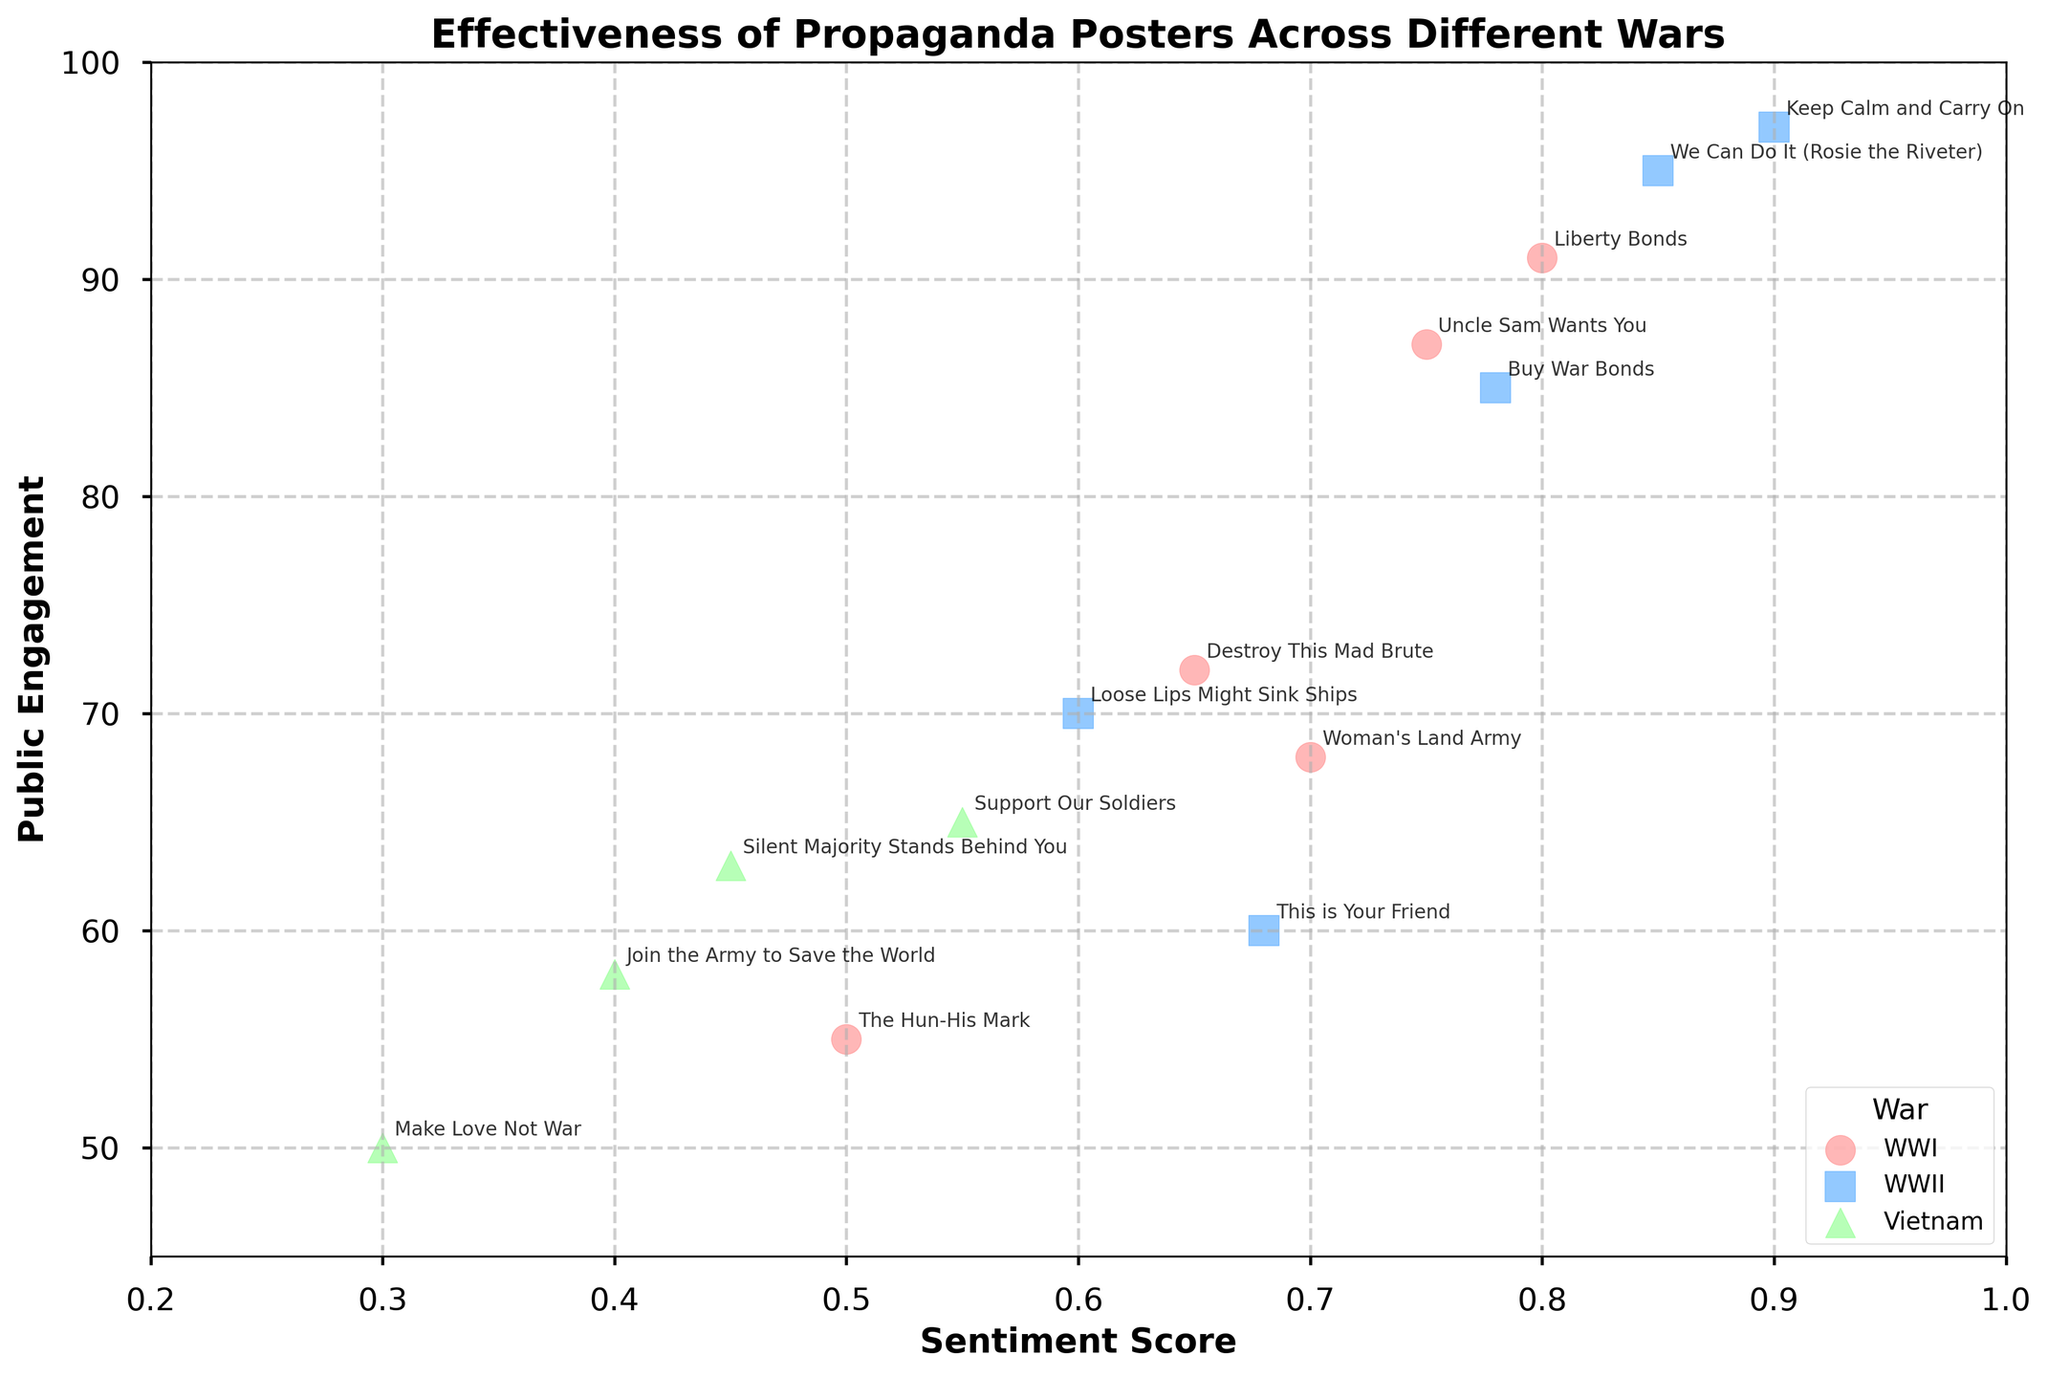What's the title of the figure? The title is typically found at the top or above the figure. Here, it states "Effectiveness of Propaganda Posters Across Different Wars".
Answer: Effectiveness of Propaganda Posters Across Different Wars How many wars are depicted in the scatter plot? The legend at the bottom right of the figure indicates each war represented by different markers and colors. The three wars are WWI, WWII, and Vietnam.
Answer: 3 Which war has the highest public engagement for a poster? By looking at the data points' y-axis values for each war, we see that WWII's "Keep Calm and Carry On" has the highest public engagement at 97.
Answer: WWII What is the general relationship between sentiment score and public engagement for WWII posters? Observing the scatter points for WWII, the trend indicates that higher sentiment scores generally correlate with higher public engagement, with peaks around 0.9 sentiment scoring 97 engagement.
Answer: Positive correlation Which poster has the lowest sentiment score in the Vietnam war, and what is its public engagement? By checking the data points for Vietnam, "Make Love Not War" has the lowest sentiment score at 0.30 with a public engagement of 50.
Answer: Make Love Not War, 50 What is the difference in sentiment score between "Uncle Sam Wants You" and "Loose Lips Might Sink Ships"? "Uncle Sam Wants You" has a sentiment score of 0.75, and "Loose Lips Might Sink Ships" has 0.60. The difference is 0.75 - 0.60.
Answer: 0.15 Looking at WWI posters, which one has the highest public engagement, and how much is it? Observing the WWI data points, "Liberty Bonds" has the highest public engagement at 91.
Answer: Liberty Bonds, 91 What is the median sentiment score of all posters in the scatter plot? To find the median, sort all sentiment scores (0.3, 0.4, 0.45, 0.5, 0.55, 0.6, 0.65, 0.68, 0.7, 0.75, 0.78, 0.8, 0.85, 0.9). The middle values are 0.65 and 0.68. The median is (0.65 + 0.68)/2.
Answer: 0.665 Which propaganda poster from WWII has both high sentiment score and high public engagement? "Keep Calm and Carry On" has a sentiment score of 0.90 and public engagement of 97, making it high in both aspects.
Answer: Keep Calm and Carry On 